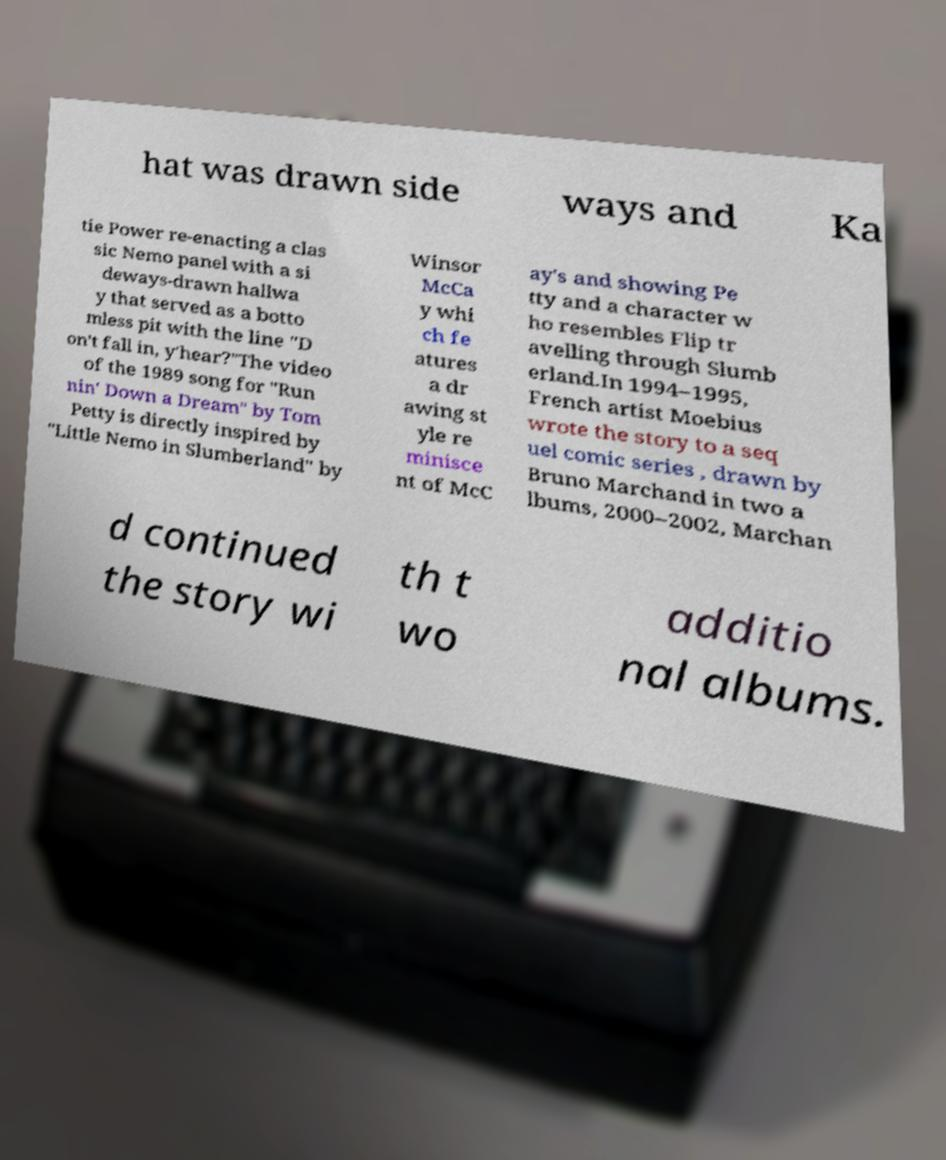Please read and relay the text visible in this image. What does it say? hat was drawn side ways and Ka tie Power re-enacting a clas sic Nemo panel with a si deways-drawn hallwa y that served as a botto mless pit with the line "D on't fall in, y'hear?"The video of the 1989 song for "Run nin' Down a Dream" by Tom Petty is directly inspired by "Little Nemo in Slumberland" by Winsor McCa y whi ch fe atures a dr awing st yle re minisce nt of McC ay's and showing Pe tty and a character w ho resembles Flip tr avelling through Slumb erland.In 1994–1995, French artist Moebius wrote the story to a seq uel comic series , drawn by Bruno Marchand in two a lbums, 2000–2002, Marchan d continued the story wi th t wo additio nal albums. 